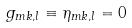Convert formula to latex. <formula><loc_0><loc_0><loc_500><loc_500>g _ { m k , l } \equiv \eta _ { m k , l } = 0</formula> 